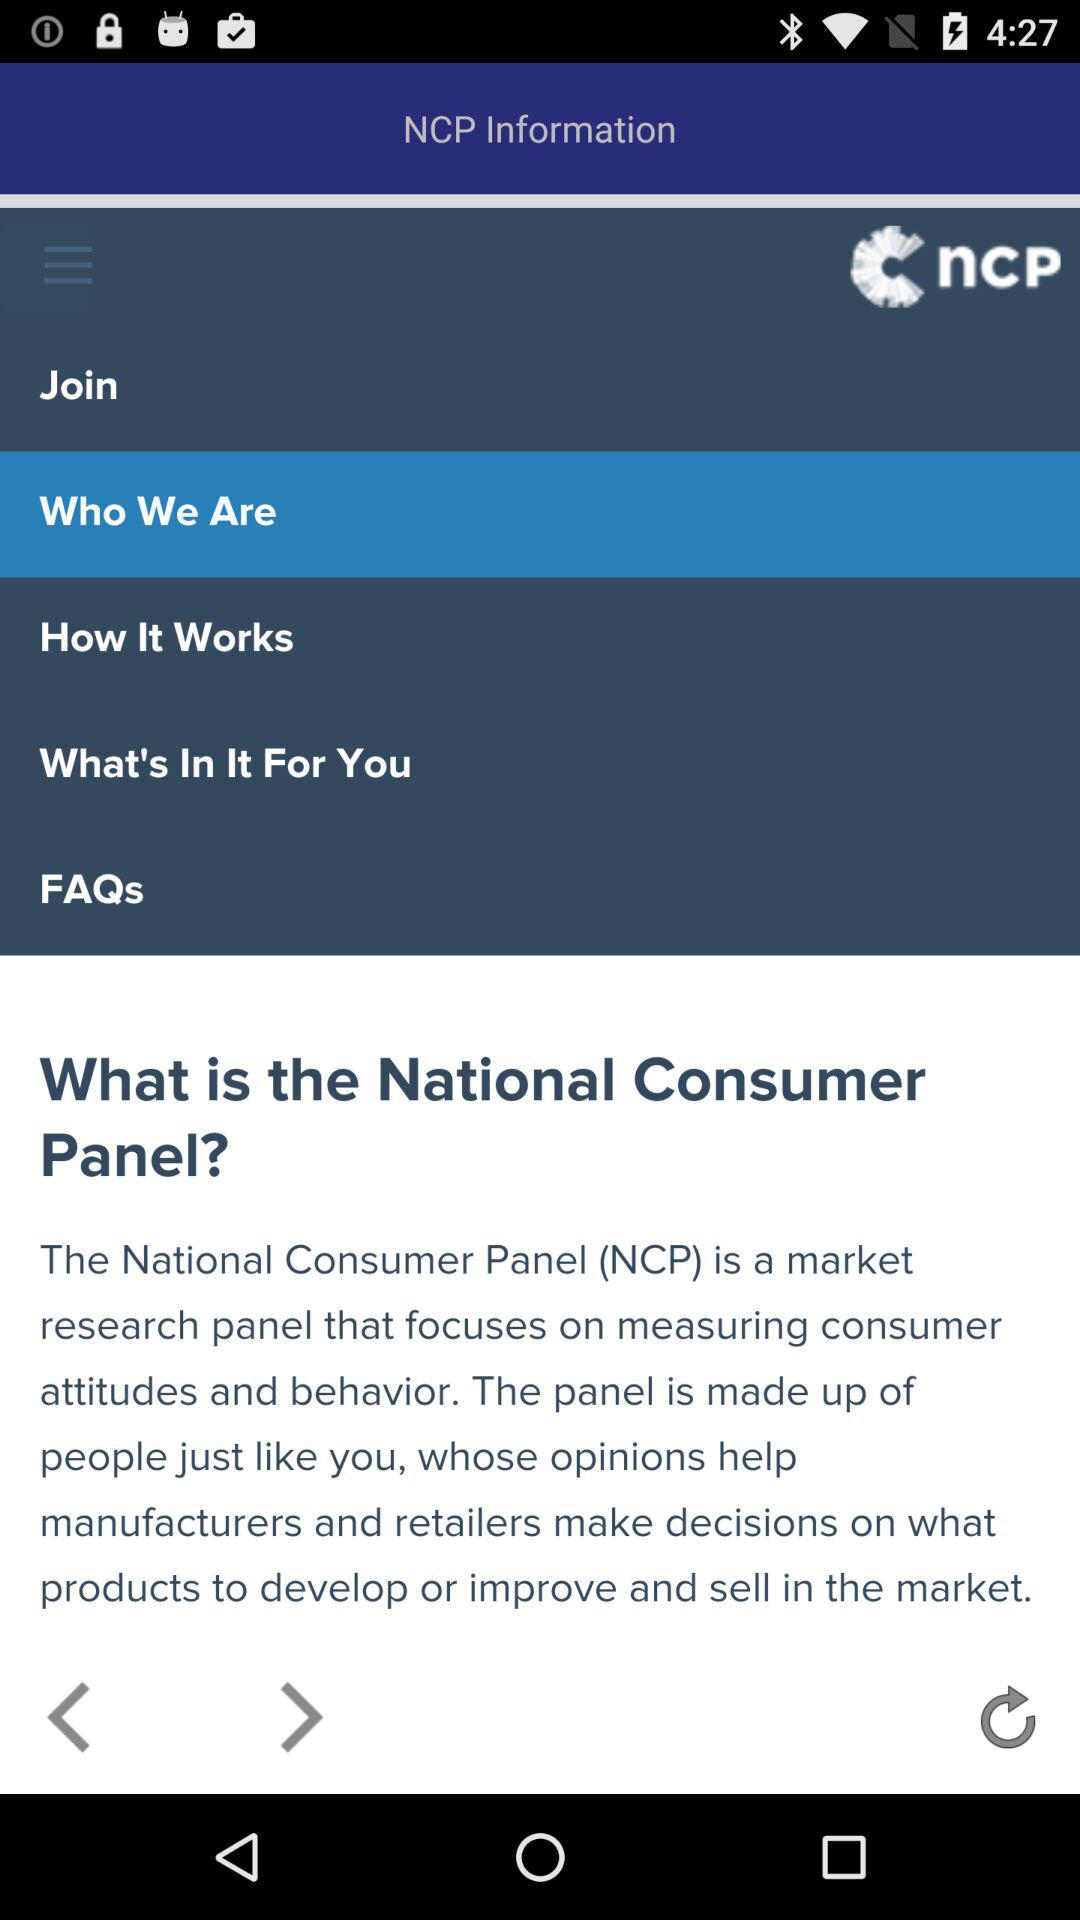What is the full form of NCP? The full form of NCP is the National Consumer Panel. 